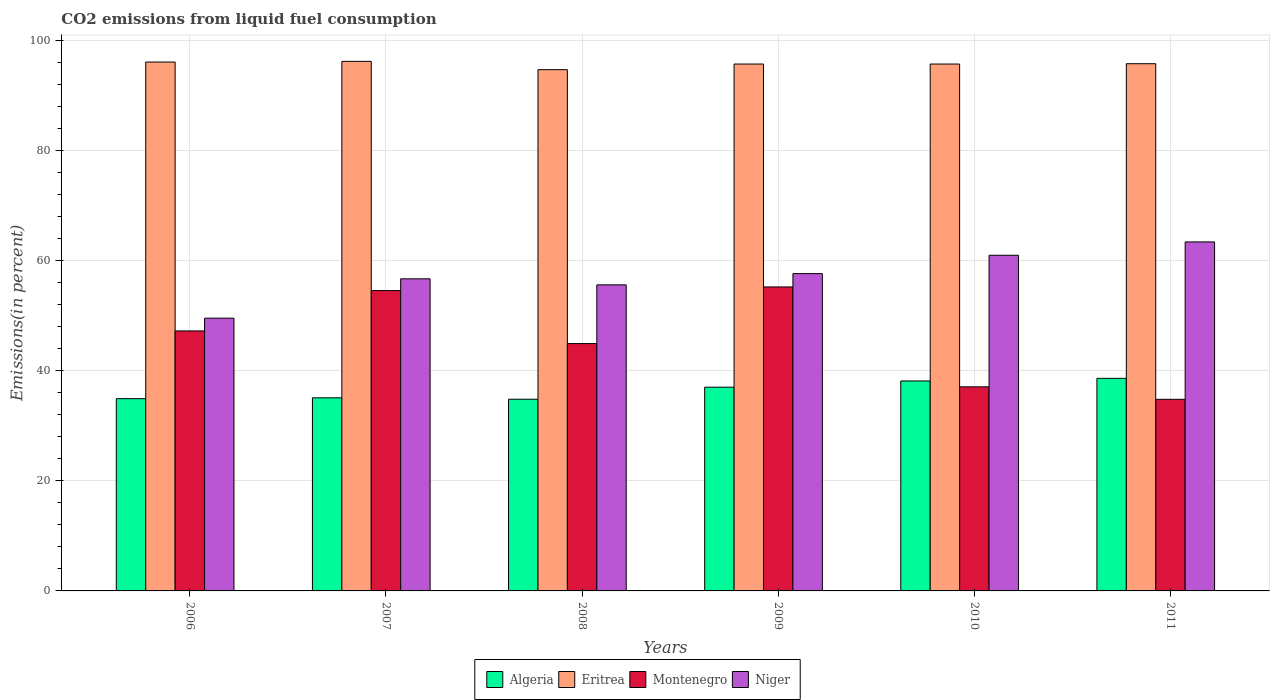How many different coloured bars are there?
Your answer should be very brief. 4. How many groups of bars are there?
Your answer should be compact. 6. Are the number of bars per tick equal to the number of legend labels?
Provide a short and direct response. Yes. How many bars are there on the 4th tick from the right?
Keep it short and to the point. 4. What is the label of the 6th group of bars from the left?
Your answer should be compact. 2011. In how many cases, is the number of bars for a given year not equal to the number of legend labels?
Provide a succinct answer. 0. What is the total CO2 emitted in Montenegro in 2011?
Provide a short and direct response. 34.81. Across all years, what is the maximum total CO2 emitted in Eritrea?
Make the answer very short. 96.2. Across all years, what is the minimum total CO2 emitted in Algeria?
Keep it short and to the point. 34.82. In which year was the total CO2 emitted in Montenegro minimum?
Your answer should be compact. 2011. What is the total total CO2 emitted in Algeria in the graph?
Make the answer very short. 218.6. What is the difference between the total CO2 emitted in Niger in 2010 and that in 2011?
Your response must be concise. -2.43. What is the difference between the total CO2 emitted in Montenegro in 2011 and the total CO2 emitted in Eritrea in 2010?
Provide a short and direct response. -60.91. What is the average total CO2 emitted in Niger per year?
Your answer should be compact. 57.31. In the year 2011, what is the difference between the total CO2 emitted in Eritrea and total CO2 emitted in Niger?
Provide a short and direct response. 32.37. What is the ratio of the total CO2 emitted in Algeria in 2009 to that in 2011?
Make the answer very short. 0.96. Is the total CO2 emitted in Eritrea in 2008 less than that in 2010?
Your answer should be compact. Yes. Is the difference between the total CO2 emitted in Eritrea in 2008 and 2009 greater than the difference between the total CO2 emitted in Niger in 2008 and 2009?
Offer a very short reply. Yes. What is the difference between the highest and the second highest total CO2 emitted in Eritrea?
Ensure brevity in your answer.  0.12. What is the difference between the highest and the lowest total CO2 emitted in Niger?
Your answer should be compact. 13.86. In how many years, is the total CO2 emitted in Algeria greater than the average total CO2 emitted in Algeria taken over all years?
Offer a terse response. 3. Is the sum of the total CO2 emitted in Algeria in 2008 and 2010 greater than the maximum total CO2 emitted in Niger across all years?
Your response must be concise. Yes. What does the 3rd bar from the left in 2006 represents?
Your response must be concise. Montenegro. What does the 2nd bar from the right in 2008 represents?
Your response must be concise. Montenegro. How many bars are there?
Your answer should be very brief. 24. Does the graph contain grids?
Your answer should be very brief. Yes. Where does the legend appear in the graph?
Give a very brief answer. Bottom center. How many legend labels are there?
Give a very brief answer. 4. What is the title of the graph?
Keep it short and to the point. CO2 emissions from liquid fuel consumption. What is the label or title of the Y-axis?
Make the answer very short. Emissions(in percent). What is the Emissions(in percent) in Algeria in 2006?
Make the answer very short. 34.93. What is the Emissions(in percent) of Eritrea in 2006?
Give a very brief answer. 96.08. What is the Emissions(in percent) of Montenegro in 2006?
Keep it short and to the point. 47.23. What is the Emissions(in percent) of Niger in 2006?
Keep it short and to the point. 49.55. What is the Emissions(in percent) in Algeria in 2007?
Your response must be concise. 35.08. What is the Emissions(in percent) in Eritrea in 2007?
Give a very brief answer. 96.2. What is the Emissions(in percent) of Montenegro in 2007?
Provide a short and direct response. 54.56. What is the Emissions(in percent) of Niger in 2007?
Ensure brevity in your answer.  56.7. What is the Emissions(in percent) in Algeria in 2008?
Keep it short and to the point. 34.82. What is the Emissions(in percent) in Eritrea in 2008?
Keep it short and to the point. 94.69. What is the Emissions(in percent) of Montenegro in 2008?
Keep it short and to the point. 44.93. What is the Emissions(in percent) in Niger in 2008?
Provide a short and direct response. 55.6. What is the Emissions(in percent) of Algeria in 2009?
Your answer should be very brief. 37.01. What is the Emissions(in percent) of Eritrea in 2009?
Offer a terse response. 95.71. What is the Emissions(in percent) in Montenegro in 2009?
Your answer should be compact. 55.22. What is the Emissions(in percent) in Niger in 2009?
Ensure brevity in your answer.  57.64. What is the Emissions(in percent) in Algeria in 2010?
Provide a succinct answer. 38.14. What is the Emissions(in percent) of Eritrea in 2010?
Provide a succinct answer. 95.71. What is the Emissions(in percent) in Montenegro in 2010?
Your answer should be compact. 37.07. What is the Emissions(in percent) of Niger in 2010?
Make the answer very short. 60.98. What is the Emissions(in percent) of Algeria in 2011?
Offer a terse response. 38.62. What is the Emissions(in percent) in Eritrea in 2011?
Ensure brevity in your answer.  95.77. What is the Emissions(in percent) in Montenegro in 2011?
Your response must be concise. 34.81. What is the Emissions(in percent) of Niger in 2011?
Provide a short and direct response. 63.4. Across all years, what is the maximum Emissions(in percent) in Algeria?
Make the answer very short. 38.62. Across all years, what is the maximum Emissions(in percent) in Eritrea?
Provide a short and direct response. 96.2. Across all years, what is the maximum Emissions(in percent) in Montenegro?
Give a very brief answer. 55.22. Across all years, what is the maximum Emissions(in percent) in Niger?
Provide a short and direct response. 63.4. Across all years, what is the minimum Emissions(in percent) in Algeria?
Your answer should be very brief. 34.82. Across all years, what is the minimum Emissions(in percent) of Eritrea?
Make the answer very short. 94.69. Across all years, what is the minimum Emissions(in percent) in Montenegro?
Offer a terse response. 34.81. Across all years, what is the minimum Emissions(in percent) of Niger?
Keep it short and to the point. 49.55. What is the total Emissions(in percent) of Algeria in the graph?
Your answer should be compact. 218.6. What is the total Emissions(in percent) of Eritrea in the graph?
Your response must be concise. 574.17. What is the total Emissions(in percent) of Montenegro in the graph?
Keep it short and to the point. 273.83. What is the total Emissions(in percent) in Niger in the graph?
Offer a very short reply. 343.86. What is the difference between the Emissions(in percent) of Algeria in 2006 and that in 2007?
Keep it short and to the point. -0.15. What is the difference between the Emissions(in percent) of Eritrea in 2006 and that in 2007?
Your response must be concise. -0.12. What is the difference between the Emissions(in percent) of Montenegro in 2006 and that in 2007?
Your answer should be compact. -7.33. What is the difference between the Emissions(in percent) in Niger in 2006 and that in 2007?
Give a very brief answer. -7.15. What is the difference between the Emissions(in percent) of Algeria in 2006 and that in 2008?
Your answer should be very brief. 0.1. What is the difference between the Emissions(in percent) in Eritrea in 2006 and that in 2008?
Give a very brief answer. 1.39. What is the difference between the Emissions(in percent) in Montenegro in 2006 and that in 2008?
Provide a short and direct response. 2.3. What is the difference between the Emissions(in percent) in Niger in 2006 and that in 2008?
Provide a succinct answer. -6.05. What is the difference between the Emissions(in percent) of Algeria in 2006 and that in 2009?
Ensure brevity in your answer.  -2.09. What is the difference between the Emissions(in percent) of Eritrea in 2006 and that in 2009?
Give a very brief answer. 0.36. What is the difference between the Emissions(in percent) of Montenegro in 2006 and that in 2009?
Keep it short and to the point. -7.99. What is the difference between the Emissions(in percent) in Niger in 2006 and that in 2009?
Provide a succinct answer. -8.1. What is the difference between the Emissions(in percent) of Algeria in 2006 and that in 2010?
Your answer should be very brief. -3.21. What is the difference between the Emissions(in percent) of Eritrea in 2006 and that in 2010?
Ensure brevity in your answer.  0.36. What is the difference between the Emissions(in percent) of Montenegro in 2006 and that in 2010?
Provide a succinct answer. 10.16. What is the difference between the Emissions(in percent) in Niger in 2006 and that in 2010?
Ensure brevity in your answer.  -11.43. What is the difference between the Emissions(in percent) of Algeria in 2006 and that in 2011?
Keep it short and to the point. -3.69. What is the difference between the Emissions(in percent) in Eritrea in 2006 and that in 2011?
Your response must be concise. 0.3. What is the difference between the Emissions(in percent) of Montenegro in 2006 and that in 2011?
Your response must be concise. 12.42. What is the difference between the Emissions(in percent) of Niger in 2006 and that in 2011?
Keep it short and to the point. -13.86. What is the difference between the Emissions(in percent) in Algeria in 2007 and that in 2008?
Offer a very short reply. 0.25. What is the difference between the Emissions(in percent) in Eritrea in 2007 and that in 2008?
Make the answer very short. 1.51. What is the difference between the Emissions(in percent) of Montenegro in 2007 and that in 2008?
Ensure brevity in your answer.  9.63. What is the difference between the Emissions(in percent) of Niger in 2007 and that in 2008?
Ensure brevity in your answer.  1.1. What is the difference between the Emissions(in percent) of Algeria in 2007 and that in 2009?
Your answer should be compact. -1.94. What is the difference between the Emissions(in percent) in Eritrea in 2007 and that in 2009?
Provide a succinct answer. 0.49. What is the difference between the Emissions(in percent) in Montenegro in 2007 and that in 2009?
Give a very brief answer. -0.66. What is the difference between the Emissions(in percent) of Niger in 2007 and that in 2009?
Offer a terse response. -0.95. What is the difference between the Emissions(in percent) of Algeria in 2007 and that in 2010?
Ensure brevity in your answer.  -3.06. What is the difference between the Emissions(in percent) in Eritrea in 2007 and that in 2010?
Provide a succinct answer. 0.49. What is the difference between the Emissions(in percent) in Montenegro in 2007 and that in 2010?
Your answer should be compact. 17.49. What is the difference between the Emissions(in percent) of Niger in 2007 and that in 2010?
Provide a short and direct response. -4.28. What is the difference between the Emissions(in percent) in Algeria in 2007 and that in 2011?
Make the answer very short. -3.54. What is the difference between the Emissions(in percent) in Eritrea in 2007 and that in 2011?
Your answer should be compact. 0.43. What is the difference between the Emissions(in percent) of Montenegro in 2007 and that in 2011?
Your answer should be compact. 19.75. What is the difference between the Emissions(in percent) in Niger in 2007 and that in 2011?
Ensure brevity in your answer.  -6.71. What is the difference between the Emissions(in percent) of Algeria in 2008 and that in 2009?
Provide a succinct answer. -2.19. What is the difference between the Emissions(in percent) of Eritrea in 2008 and that in 2009?
Your answer should be compact. -1.02. What is the difference between the Emissions(in percent) of Montenegro in 2008 and that in 2009?
Provide a short and direct response. -10.29. What is the difference between the Emissions(in percent) of Niger in 2008 and that in 2009?
Provide a succinct answer. -2.04. What is the difference between the Emissions(in percent) in Algeria in 2008 and that in 2010?
Provide a succinct answer. -3.32. What is the difference between the Emissions(in percent) in Eritrea in 2008 and that in 2010?
Keep it short and to the point. -1.02. What is the difference between the Emissions(in percent) in Montenegro in 2008 and that in 2010?
Ensure brevity in your answer.  7.86. What is the difference between the Emissions(in percent) in Niger in 2008 and that in 2010?
Provide a succinct answer. -5.38. What is the difference between the Emissions(in percent) of Algeria in 2008 and that in 2011?
Your answer should be compact. -3.79. What is the difference between the Emissions(in percent) of Eritrea in 2008 and that in 2011?
Your response must be concise. -1.08. What is the difference between the Emissions(in percent) in Montenegro in 2008 and that in 2011?
Provide a short and direct response. 10.13. What is the difference between the Emissions(in percent) in Niger in 2008 and that in 2011?
Your answer should be very brief. -7.8. What is the difference between the Emissions(in percent) of Algeria in 2009 and that in 2010?
Offer a very short reply. -1.13. What is the difference between the Emissions(in percent) in Montenegro in 2009 and that in 2010?
Provide a succinct answer. 18.15. What is the difference between the Emissions(in percent) of Niger in 2009 and that in 2010?
Provide a succinct answer. -3.33. What is the difference between the Emissions(in percent) in Algeria in 2009 and that in 2011?
Give a very brief answer. -1.6. What is the difference between the Emissions(in percent) in Eritrea in 2009 and that in 2011?
Offer a terse response. -0.06. What is the difference between the Emissions(in percent) in Montenegro in 2009 and that in 2011?
Make the answer very short. 20.41. What is the difference between the Emissions(in percent) in Niger in 2009 and that in 2011?
Provide a short and direct response. -5.76. What is the difference between the Emissions(in percent) of Algeria in 2010 and that in 2011?
Your answer should be compact. -0.48. What is the difference between the Emissions(in percent) in Eritrea in 2010 and that in 2011?
Your response must be concise. -0.06. What is the difference between the Emissions(in percent) of Montenegro in 2010 and that in 2011?
Give a very brief answer. 2.27. What is the difference between the Emissions(in percent) of Niger in 2010 and that in 2011?
Make the answer very short. -2.43. What is the difference between the Emissions(in percent) in Algeria in 2006 and the Emissions(in percent) in Eritrea in 2007?
Your response must be concise. -61.28. What is the difference between the Emissions(in percent) in Algeria in 2006 and the Emissions(in percent) in Montenegro in 2007?
Ensure brevity in your answer.  -19.63. What is the difference between the Emissions(in percent) of Algeria in 2006 and the Emissions(in percent) of Niger in 2007?
Provide a succinct answer. -21.77. What is the difference between the Emissions(in percent) in Eritrea in 2006 and the Emissions(in percent) in Montenegro in 2007?
Offer a terse response. 41.52. What is the difference between the Emissions(in percent) of Eritrea in 2006 and the Emissions(in percent) of Niger in 2007?
Provide a short and direct response. 39.38. What is the difference between the Emissions(in percent) in Montenegro in 2006 and the Emissions(in percent) in Niger in 2007?
Your answer should be compact. -9.47. What is the difference between the Emissions(in percent) in Algeria in 2006 and the Emissions(in percent) in Eritrea in 2008?
Offer a terse response. -59.76. What is the difference between the Emissions(in percent) in Algeria in 2006 and the Emissions(in percent) in Montenegro in 2008?
Make the answer very short. -10.01. What is the difference between the Emissions(in percent) in Algeria in 2006 and the Emissions(in percent) in Niger in 2008?
Ensure brevity in your answer.  -20.67. What is the difference between the Emissions(in percent) in Eritrea in 2006 and the Emissions(in percent) in Montenegro in 2008?
Give a very brief answer. 51.15. What is the difference between the Emissions(in percent) of Eritrea in 2006 and the Emissions(in percent) of Niger in 2008?
Your response must be concise. 40.48. What is the difference between the Emissions(in percent) of Montenegro in 2006 and the Emissions(in percent) of Niger in 2008?
Provide a short and direct response. -8.37. What is the difference between the Emissions(in percent) in Algeria in 2006 and the Emissions(in percent) in Eritrea in 2009?
Offer a terse response. -60.79. What is the difference between the Emissions(in percent) of Algeria in 2006 and the Emissions(in percent) of Montenegro in 2009?
Provide a succinct answer. -20.29. What is the difference between the Emissions(in percent) in Algeria in 2006 and the Emissions(in percent) in Niger in 2009?
Give a very brief answer. -22.72. What is the difference between the Emissions(in percent) in Eritrea in 2006 and the Emissions(in percent) in Montenegro in 2009?
Provide a short and direct response. 40.86. What is the difference between the Emissions(in percent) in Eritrea in 2006 and the Emissions(in percent) in Niger in 2009?
Make the answer very short. 38.44. What is the difference between the Emissions(in percent) of Montenegro in 2006 and the Emissions(in percent) of Niger in 2009?
Ensure brevity in your answer.  -10.41. What is the difference between the Emissions(in percent) of Algeria in 2006 and the Emissions(in percent) of Eritrea in 2010?
Your answer should be very brief. -60.79. What is the difference between the Emissions(in percent) of Algeria in 2006 and the Emissions(in percent) of Montenegro in 2010?
Offer a terse response. -2.15. What is the difference between the Emissions(in percent) in Algeria in 2006 and the Emissions(in percent) in Niger in 2010?
Provide a succinct answer. -26.05. What is the difference between the Emissions(in percent) of Eritrea in 2006 and the Emissions(in percent) of Montenegro in 2010?
Your answer should be very brief. 59. What is the difference between the Emissions(in percent) of Eritrea in 2006 and the Emissions(in percent) of Niger in 2010?
Your answer should be compact. 35.1. What is the difference between the Emissions(in percent) of Montenegro in 2006 and the Emissions(in percent) of Niger in 2010?
Provide a succinct answer. -13.74. What is the difference between the Emissions(in percent) in Algeria in 2006 and the Emissions(in percent) in Eritrea in 2011?
Make the answer very short. -60.85. What is the difference between the Emissions(in percent) of Algeria in 2006 and the Emissions(in percent) of Montenegro in 2011?
Provide a succinct answer. 0.12. What is the difference between the Emissions(in percent) of Algeria in 2006 and the Emissions(in percent) of Niger in 2011?
Provide a succinct answer. -28.48. What is the difference between the Emissions(in percent) of Eritrea in 2006 and the Emissions(in percent) of Montenegro in 2011?
Your answer should be very brief. 61.27. What is the difference between the Emissions(in percent) of Eritrea in 2006 and the Emissions(in percent) of Niger in 2011?
Ensure brevity in your answer.  32.68. What is the difference between the Emissions(in percent) of Montenegro in 2006 and the Emissions(in percent) of Niger in 2011?
Your answer should be compact. -16.17. What is the difference between the Emissions(in percent) in Algeria in 2007 and the Emissions(in percent) in Eritrea in 2008?
Make the answer very short. -59.61. What is the difference between the Emissions(in percent) in Algeria in 2007 and the Emissions(in percent) in Montenegro in 2008?
Keep it short and to the point. -9.86. What is the difference between the Emissions(in percent) of Algeria in 2007 and the Emissions(in percent) of Niger in 2008?
Offer a terse response. -20.52. What is the difference between the Emissions(in percent) of Eritrea in 2007 and the Emissions(in percent) of Montenegro in 2008?
Provide a succinct answer. 51.27. What is the difference between the Emissions(in percent) of Eritrea in 2007 and the Emissions(in percent) of Niger in 2008?
Keep it short and to the point. 40.6. What is the difference between the Emissions(in percent) in Montenegro in 2007 and the Emissions(in percent) in Niger in 2008?
Keep it short and to the point. -1.04. What is the difference between the Emissions(in percent) in Algeria in 2007 and the Emissions(in percent) in Eritrea in 2009?
Your response must be concise. -60.64. What is the difference between the Emissions(in percent) in Algeria in 2007 and the Emissions(in percent) in Montenegro in 2009?
Provide a succinct answer. -20.14. What is the difference between the Emissions(in percent) of Algeria in 2007 and the Emissions(in percent) of Niger in 2009?
Provide a short and direct response. -22.57. What is the difference between the Emissions(in percent) of Eritrea in 2007 and the Emissions(in percent) of Montenegro in 2009?
Offer a terse response. 40.98. What is the difference between the Emissions(in percent) in Eritrea in 2007 and the Emissions(in percent) in Niger in 2009?
Your response must be concise. 38.56. What is the difference between the Emissions(in percent) of Montenegro in 2007 and the Emissions(in percent) of Niger in 2009?
Keep it short and to the point. -3.08. What is the difference between the Emissions(in percent) of Algeria in 2007 and the Emissions(in percent) of Eritrea in 2010?
Offer a terse response. -60.64. What is the difference between the Emissions(in percent) in Algeria in 2007 and the Emissions(in percent) in Montenegro in 2010?
Give a very brief answer. -2. What is the difference between the Emissions(in percent) in Algeria in 2007 and the Emissions(in percent) in Niger in 2010?
Your answer should be very brief. -25.9. What is the difference between the Emissions(in percent) in Eritrea in 2007 and the Emissions(in percent) in Montenegro in 2010?
Keep it short and to the point. 59.13. What is the difference between the Emissions(in percent) in Eritrea in 2007 and the Emissions(in percent) in Niger in 2010?
Your answer should be compact. 35.23. What is the difference between the Emissions(in percent) of Montenegro in 2007 and the Emissions(in percent) of Niger in 2010?
Make the answer very short. -6.42. What is the difference between the Emissions(in percent) of Algeria in 2007 and the Emissions(in percent) of Eritrea in 2011?
Your answer should be compact. -60.7. What is the difference between the Emissions(in percent) of Algeria in 2007 and the Emissions(in percent) of Montenegro in 2011?
Provide a short and direct response. 0.27. What is the difference between the Emissions(in percent) in Algeria in 2007 and the Emissions(in percent) in Niger in 2011?
Provide a succinct answer. -28.32. What is the difference between the Emissions(in percent) in Eritrea in 2007 and the Emissions(in percent) in Montenegro in 2011?
Make the answer very short. 61.4. What is the difference between the Emissions(in percent) in Eritrea in 2007 and the Emissions(in percent) in Niger in 2011?
Your answer should be very brief. 32.8. What is the difference between the Emissions(in percent) of Montenegro in 2007 and the Emissions(in percent) of Niger in 2011?
Provide a succinct answer. -8.84. What is the difference between the Emissions(in percent) in Algeria in 2008 and the Emissions(in percent) in Eritrea in 2009?
Offer a terse response. -60.89. What is the difference between the Emissions(in percent) of Algeria in 2008 and the Emissions(in percent) of Montenegro in 2009?
Ensure brevity in your answer.  -20.4. What is the difference between the Emissions(in percent) in Algeria in 2008 and the Emissions(in percent) in Niger in 2009?
Your answer should be compact. -22.82. What is the difference between the Emissions(in percent) in Eritrea in 2008 and the Emissions(in percent) in Montenegro in 2009?
Ensure brevity in your answer.  39.47. What is the difference between the Emissions(in percent) of Eritrea in 2008 and the Emissions(in percent) of Niger in 2009?
Give a very brief answer. 37.05. What is the difference between the Emissions(in percent) in Montenegro in 2008 and the Emissions(in percent) in Niger in 2009?
Offer a terse response. -12.71. What is the difference between the Emissions(in percent) of Algeria in 2008 and the Emissions(in percent) of Eritrea in 2010?
Ensure brevity in your answer.  -60.89. What is the difference between the Emissions(in percent) of Algeria in 2008 and the Emissions(in percent) of Montenegro in 2010?
Provide a succinct answer. -2.25. What is the difference between the Emissions(in percent) of Algeria in 2008 and the Emissions(in percent) of Niger in 2010?
Offer a terse response. -26.15. What is the difference between the Emissions(in percent) in Eritrea in 2008 and the Emissions(in percent) in Montenegro in 2010?
Your answer should be compact. 57.62. What is the difference between the Emissions(in percent) in Eritrea in 2008 and the Emissions(in percent) in Niger in 2010?
Your answer should be very brief. 33.71. What is the difference between the Emissions(in percent) of Montenegro in 2008 and the Emissions(in percent) of Niger in 2010?
Your answer should be very brief. -16.04. What is the difference between the Emissions(in percent) of Algeria in 2008 and the Emissions(in percent) of Eritrea in 2011?
Offer a terse response. -60.95. What is the difference between the Emissions(in percent) of Algeria in 2008 and the Emissions(in percent) of Montenegro in 2011?
Ensure brevity in your answer.  0.02. What is the difference between the Emissions(in percent) in Algeria in 2008 and the Emissions(in percent) in Niger in 2011?
Keep it short and to the point. -28.58. What is the difference between the Emissions(in percent) of Eritrea in 2008 and the Emissions(in percent) of Montenegro in 2011?
Offer a very short reply. 59.88. What is the difference between the Emissions(in percent) in Eritrea in 2008 and the Emissions(in percent) in Niger in 2011?
Offer a terse response. 31.29. What is the difference between the Emissions(in percent) in Montenegro in 2008 and the Emissions(in percent) in Niger in 2011?
Offer a very short reply. -18.47. What is the difference between the Emissions(in percent) of Algeria in 2009 and the Emissions(in percent) of Eritrea in 2010?
Provide a succinct answer. -58.7. What is the difference between the Emissions(in percent) of Algeria in 2009 and the Emissions(in percent) of Montenegro in 2010?
Give a very brief answer. -0.06. What is the difference between the Emissions(in percent) of Algeria in 2009 and the Emissions(in percent) of Niger in 2010?
Offer a very short reply. -23.96. What is the difference between the Emissions(in percent) of Eritrea in 2009 and the Emissions(in percent) of Montenegro in 2010?
Provide a short and direct response. 58.64. What is the difference between the Emissions(in percent) in Eritrea in 2009 and the Emissions(in percent) in Niger in 2010?
Your answer should be compact. 34.74. What is the difference between the Emissions(in percent) in Montenegro in 2009 and the Emissions(in percent) in Niger in 2010?
Your answer should be very brief. -5.75. What is the difference between the Emissions(in percent) of Algeria in 2009 and the Emissions(in percent) of Eritrea in 2011?
Provide a short and direct response. -58.76. What is the difference between the Emissions(in percent) in Algeria in 2009 and the Emissions(in percent) in Montenegro in 2011?
Provide a short and direct response. 2.21. What is the difference between the Emissions(in percent) of Algeria in 2009 and the Emissions(in percent) of Niger in 2011?
Provide a succinct answer. -26.39. What is the difference between the Emissions(in percent) of Eritrea in 2009 and the Emissions(in percent) of Montenegro in 2011?
Your answer should be very brief. 60.91. What is the difference between the Emissions(in percent) in Eritrea in 2009 and the Emissions(in percent) in Niger in 2011?
Offer a very short reply. 32.31. What is the difference between the Emissions(in percent) in Montenegro in 2009 and the Emissions(in percent) in Niger in 2011?
Your response must be concise. -8.18. What is the difference between the Emissions(in percent) of Algeria in 2010 and the Emissions(in percent) of Eritrea in 2011?
Your answer should be compact. -57.63. What is the difference between the Emissions(in percent) of Algeria in 2010 and the Emissions(in percent) of Montenegro in 2011?
Give a very brief answer. 3.33. What is the difference between the Emissions(in percent) in Algeria in 2010 and the Emissions(in percent) in Niger in 2011?
Your answer should be very brief. -25.26. What is the difference between the Emissions(in percent) of Eritrea in 2010 and the Emissions(in percent) of Montenegro in 2011?
Provide a succinct answer. 60.91. What is the difference between the Emissions(in percent) in Eritrea in 2010 and the Emissions(in percent) in Niger in 2011?
Ensure brevity in your answer.  32.31. What is the difference between the Emissions(in percent) of Montenegro in 2010 and the Emissions(in percent) of Niger in 2011?
Offer a terse response. -26.33. What is the average Emissions(in percent) in Algeria per year?
Provide a succinct answer. 36.43. What is the average Emissions(in percent) in Eritrea per year?
Keep it short and to the point. 95.7. What is the average Emissions(in percent) of Montenegro per year?
Your response must be concise. 45.64. What is the average Emissions(in percent) in Niger per year?
Keep it short and to the point. 57.31. In the year 2006, what is the difference between the Emissions(in percent) in Algeria and Emissions(in percent) in Eritrea?
Provide a succinct answer. -61.15. In the year 2006, what is the difference between the Emissions(in percent) in Algeria and Emissions(in percent) in Montenegro?
Your answer should be compact. -12.3. In the year 2006, what is the difference between the Emissions(in percent) of Algeria and Emissions(in percent) of Niger?
Your answer should be compact. -14.62. In the year 2006, what is the difference between the Emissions(in percent) in Eritrea and Emissions(in percent) in Montenegro?
Your response must be concise. 48.85. In the year 2006, what is the difference between the Emissions(in percent) of Eritrea and Emissions(in percent) of Niger?
Your response must be concise. 46.53. In the year 2006, what is the difference between the Emissions(in percent) of Montenegro and Emissions(in percent) of Niger?
Make the answer very short. -2.31. In the year 2007, what is the difference between the Emissions(in percent) in Algeria and Emissions(in percent) in Eritrea?
Keep it short and to the point. -61.12. In the year 2007, what is the difference between the Emissions(in percent) of Algeria and Emissions(in percent) of Montenegro?
Keep it short and to the point. -19.48. In the year 2007, what is the difference between the Emissions(in percent) in Algeria and Emissions(in percent) in Niger?
Offer a very short reply. -21.62. In the year 2007, what is the difference between the Emissions(in percent) of Eritrea and Emissions(in percent) of Montenegro?
Offer a very short reply. 41.64. In the year 2007, what is the difference between the Emissions(in percent) of Eritrea and Emissions(in percent) of Niger?
Ensure brevity in your answer.  39.51. In the year 2007, what is the difference between the Emissions(in percent) of Montenegro and Emissions(in percent) of Niger?
Give a very brief answer. -2.14. In the year 2008, what is the difference between the Emissions(in percent) in Algeria and Emissions(in percent) in Eritrea?
Your answer should be very brief. -59.87. In the year 2008, what is the difference between the Emissions(in percent) of Algeria and Emissions(in percent) of Montenegro?
Offer a very short reply. -10.11. In the year 2008, what is the difference between the Emissions(in percent) in Algeria and Emissions(in percent) in Niger?
Offer a terse response. -20.78. In the year 2008, what is the difference between the Emissions(in percent) of Eritrea and Emissions(in percent) of Montenegro?
Make the answer very short. 49.76. In the year 2008, what is the difference between the Emissions(in percent) of Eritrea and Emissions(in percent) of Niger?
Keep it short and to the point. 39.09. In the year 2008, what is the difference between the Emissions(in percent) in Montenegro and Emissions(in percent) in Niger?
Provide a short and direct response. -10.67. In the year 2009, what is the difference between the Emissions(in percent) of Algeria and Emissions(in percent) of Eritrea?
Keep it short and to the point. -58.7. In the year 2009, what is the difference between the Emissions(in percent) of Algeria and Emissions(in percent) of Montenegro?
Keep it short and to the point. -18.21. In the year 2009, what is the difference between the Emissions(in percent) of Algeria and Emissions(in percent) of Niger?
Provide a short and direct response. -20.63. In the year 2009, what is the difference between the Emissions(in percent) of Eritrea and Emissions(in percent) of Montenegro?
Your answer should be compact. 40.49. In the year 2009, what is the difference between the Emissions(in percent) in Eritrea and Emissions(in percent) in Niger?
Your answer should be very brief. 38.07. In the year 2009, what is the difference between the Emissions(in percent) of Montenegro and Emissions(in percent) of Niger?
Provide a succinct answer. -2.42. In the year 2010, what is the difference between the Emissions(in percent) of Algeria and Emissions(in percent) of Eritrea?
Keep it short and to the point. -57.57. In the year 2010, what is the difference between the Emissions(in percent) of Algeria and Emissions(in percent) of Montenegro?
Ensure brevity in your answer.  1.07. In the year 2010, what is the difference between the Emissions(in percent) in Algeria and Emissions(in percent) in Niger?
Your response must be concise. -22.84. In the year 2010, what is the difference between the Emissions(in percent) in Eritrea and Emissions(in percent) in Montenegro?
Offer a very short reply. 58.64. In the year 2010, what is the difference between the Emissions(in percent) of Eritrea and Emissions(in percent) of Niger?
Your answer should be very brief. 34.74. In the year 2010, what is the difference between the Emissions(in percent) in Montenegro and Emissions(in percent) in Niger?
Your answer should be very brief. -23.9. In the year 2011, what is the difference between the Emissions(in percent) of Algeria and Emissions(in percent) of Eritrea?
Your answer should be very brief. -57.16. In the year 2011, what is the difference between the Emissions(in percent) of Algeria and Emissions(in percent) of Montenegro?
Keep it short and to the point. 3.81. In the year 2011, what is the difference between the Emissions(in percent) in Algeria and Emissions(in percent) in Niger?
Make the answer very short. -24.79. In the year 2011, what is the difference between the Emissions(in percent) in Eritrea and Emissions(in percent) in Montenegro?
Give a very brief answer. 60.97. In the year 2011, what is the difference between the Emissions(in percent) in Eritrea and Emissions(in percent) in Niger?
Give a very brief answer. 32.37. In the year 2011, what is the difference between the Emissions(in percent) of Montenegro and Emissions(in percent) of Niger?
Offer a terse response. -28.59. What is the ratio of the Emissions(in percent) in Montenegro in 2006 to that in 2007?
Ensure brevity in your answer.  0.87. What is the ratio of the Emissions(in percent) in Niger in 2006 to that in 2007?
Ensure brevity in your answer.  0.87. What is the ratio of the Emissions(in percent) of Algeria in 2006 to that in 2008?
Offer a terse response. 1. What is the ratio of the Emissions(in percent) in Eritrea in 2006 to that in 2008?
Offer a terse response. 1.01. What is the ratio of the Emissions(in percent) in Montenegro in 2006 to that in 2008?
Provide a succinct answer. 1.05. What is the ratio of the Emissions(in percent) of Niger in 2006 to that in 2008?
Offer a terse response. 0.89. What is the ratio of the Emissions(in percent) of Algeria in 2006 to that in 2009?
Keep it short and to the point. 0.94. What is the ratio of the Emissions(in percent) of Montenegro in 2006 to that in 2009?
Your answer should be compact. 0.86. What is the ratio of the Emissions(in percent) of Niger in 2006 to that in 2009?
Your response must be concise. 0.86. What is the ratio of the Emissions(in percent) of Algeria in 2006 to that in 2010?
Provide a succinct answer. 0.92. What is the ratio of the Emissions(in percent) of Eritrea in 2006 to that in 2010?
Offer a terse response. 1. What is the ratio of the Emissions(in percent) in Montenegro in 2006 to that in 2010?
Give a very brief answer. 1.27. What is the ratio of the Emissions(in percent) of Niger in 2006 to that in 2010?
Keep it short and to the point. 0.81. What is the ratio of the Emissions(in percent) in Algeria in 2006 to that in 2011?
Give a very brief answer. 0.9. What is the ratio of the Emissions(in percent) in Montenegro in 2006 to that in 2011?
Keep it short and to the point. 1.36. What is the ratio of the Emissions(in percent) in Niger in 2006 to that in 2011?
Offer a terse response. 0.78. What is the ratio of the Emissions(in percent) in Algeria in 2007 to that in 2008?
Provide a succinct answer. 1.01. What is the ratio of the Emissions(in percent) of Montenegro in 2007 to that in 2008?
Offer a very short reply. 1.21. What is the ratio of the Emissions(in percent) in Niger in 2007 to that in 2008?
Offer a terse response. 1.02. What is the ratio of the Emissions(in percent) of Algeria in 2007 to that in 2009?
Keep it short and to the point. 0.95. What is the ratio of the Emissions(in percent) in Eritrea in 2007 to that in 2009?
Keep it short and to the point. 1.01. What is the ratio of the Emissions(in percent) in Montenegro in 2007 to that in 2009?
Provide a succinct answer. 0.99. What is the ratio of the Emissions(in percent) in Niger in 2007 to that in 2009?
Provide a short and direct response. 0.98. What is the ratio of the Emissions(in percent) in Algeria in 2007 to that in 2010?
Give a very brief answer. 0.92. What is the ratio of the Emissions(in percent) in Montenegro in 2007 to that in 2010?
Your response must be concise. 1.47. What is the ratio of the Emissions(in percent) in Niger in 2007 to that in 2010?
Your answer should be compact. 0.93. What is the ratio of the Emissions(in percent) in Algeria in 2007 to that in 2011?
Offer a very short reply. 0.91. What is the ratio of the Emissions(in percent) in Montenegro in 2007 to that in 2011?
Offer a terse response. 1.57. What is the ratio of the Emissions(in percent) in Niger in 2007 to that in 2011?
Offer a very short reply. 0.89. What is the ratio of the Emissions(in percent) of Algeria in 2008 to that in 2009?
Give a very brief answer. 0.94. What is the ratio of the Emissions(in percent) in Eritrea in 2008 to that in 2009?
Make the answer very short. 0.99. What is the ratio of the Emissions(in percent) of Montenegro in 2008 to that in 2009?
Your answer should be compact. 0.81. What is the ratio of the Emissions(in percent) in Niger in 2008 to that in 2009?
Give a very brief answer. 0.96. What is the ratio of the Emissions(in percent) of Algeria in 2008 to that in 2010?
Your answer should be very brief. 0.91. What is the ratio of the Emissions(in percent) of Eritrea in 2008 to that in 2010?
Your answer should be compact. 0.99. What is the ratio of the Emissions(in percent) of Montenegro in 2008 to that in 2010?
Offer a very short reply. 1.21. What is the ratio of the Emissions(in percent) in Niger in 2008 to that in 2010?
Make the answer very short. 0.91. What is the ratio of the Emissions(in percent) in Algeria in 2008 to that in 2011?
Ensure brevity in your answer.  0.9. What is the ratio of the Emissions(in percent) in Eritrea in 2008 to that in 2011?
Your response must be concise. 0.99. What is the ratio of the Emissions(in percent) in Montenegro in 2008 to that in 2011?
Keep it short and to the point. 1.29. What is the ratio of the Emissions(in percent) in Niger in 2008 to that in 2011?
Your answer should be compact. 0.88. What is the ratio of the Emissions(in percent) in Algeria in 2009 to that in 2010?
Give a very brief answer. 0.97. What is the ratio of the Emissions(in percent) of Montenegro in 2009 to that in 2010?
Your answer should be very brief. 1.49. What is the ratio of the Emissions(in percent) in Niger in 2009 to that in 2010?
Give a very brief answer. 0.95. What is the ratio of the Emissions(in percent) of Algeria in 2009 to that in 2011?
Provide a succinct answer. 0.96. What is the ratio of the Emissions(in percent) of Eritrea in 2009 to that in 2011?
Make the answer very short. 1. What is the ratio of the Emissions(in percent) in Montenegro in 2009 to that in 2011?
Make the answer very short. 1.59. What is the ratio of the Emissions(in percent) in Niger in 2009 to that in 2011?
Give a very brief answer. 0.91. What is the ratio of the Emissions(in percent) in Algeria in 2010 to that in 2011?
Offer a very short reply. 0.99. What is the ratio of the Emissions(in percent) of Eritrea in 2010 to that in 2011?
Your answer should be very brief. 1. What is the ratio of the Emissions(in percent) in Montenegro in 2010 to that in 2011?
Your answer should be very brief. 1.07. What is the ratio of the Emissions(in percent) in Niger in 2010 to that in 2011?
Offer a terse response. 0.96. What is the difference between the highest and the second highest Emissions(in percent) in Algeria?
Give a very brief answer. 0.48. What is the difference between the highest and the second highest Emissions(in percent) of Eritrea?
Keep it short and to the point. 0.12. What is the difference between the highest and the second highest Emissions(in percent) in Montenegro?
Provide a succinct answer. 0.66. What is the difference between the highest and the second highest Emissions(in percent) of Niger?
Make the answer very short. 2.43. What is the difference between the highest and the lowest Emissions(in percent) of Algeria?
Ensure brevity in your answer.  3.79. What is the difference between the highest and the lowest Emissions(in percent) in Eritrea?
Your answer should be very brief. 1.51. What is the difference between the highest and the lowest Emissions(in percent) in Montenegro?
Make the answer very short. 20.41. What is the difference between the highest and the lowest Emissions(in percent) of Niger?
Provide a short and direct response. 13.86. 